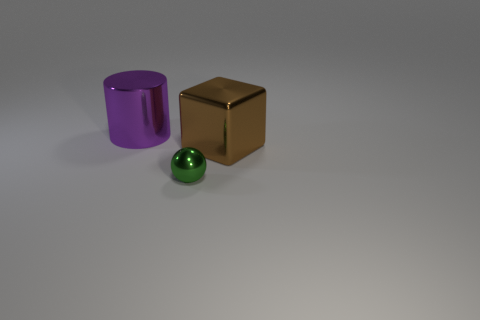What is the shape of the metal object that is the same size as the shiny cylinder?
Keep it short and to the point. Cube. What is the size of the brown metal object?
Provide a short and direct response. Large. Is the size of the metal thing left of the small metal sphere the same as the thing in front of the brown thing?
Keep it short and to the point. No. There is a large object on the right side of the metal object to the left of the small green metal ball; what is its color?
Offer a very short reply. Brown. What material is the purple cylinder that is the same size as the brown object?
Your answer should be very brief. Metal. How many metallic things are either big cyan cubes or cylinders?
Provide a short and direct response. 1. What color is the shiny thing that is both in front of the purple shiny object and behind the tiny object?
Your answer should be very brief. Brown. There is a small green metallic sphere; what number of large objects are to the left of it?
Your response must be concise. 1. What is the green ball made of?
Give a very brief answer. Metal. What color is the large object that is behind the big thing that is in front of the big thing that is behind the brown object?
Your response must be concise. Purple. 